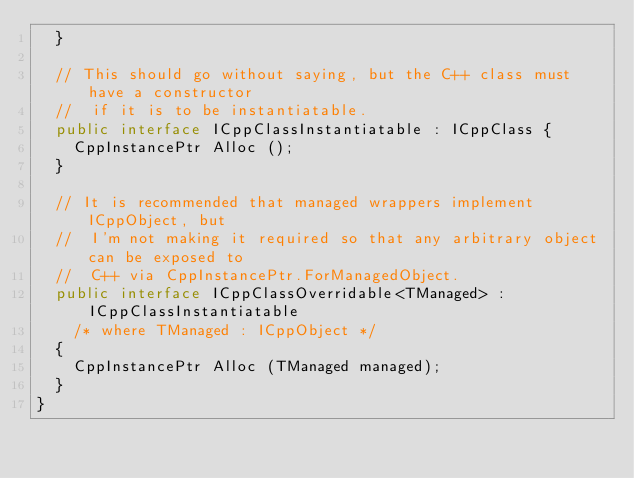<code> <loc_0><loc_0><loc_500><loc_500><_C#_>	}

	// This should go without saying, but the C++ class must have a constructor
	//  if it is to be instantiatable.
	public interface ICppClassInstantiatable : ICppClass {
		CppInstancePtr Alloc ();
	}

	// It is recommended that managed wrappers implement ICppObject, but
	//  I'm not making it required so that any arbitrary object can be exposed to
	//  C++ via CppInstancePtr.ForManagedObject.
	public interface ICppClassOverridable<TManaged> : ICppClassInstantiatable
		/* where TManaged : ICppObject */
	{
		CppInstancePtr Alloc (TManaged managed);
	}
}
</code> 